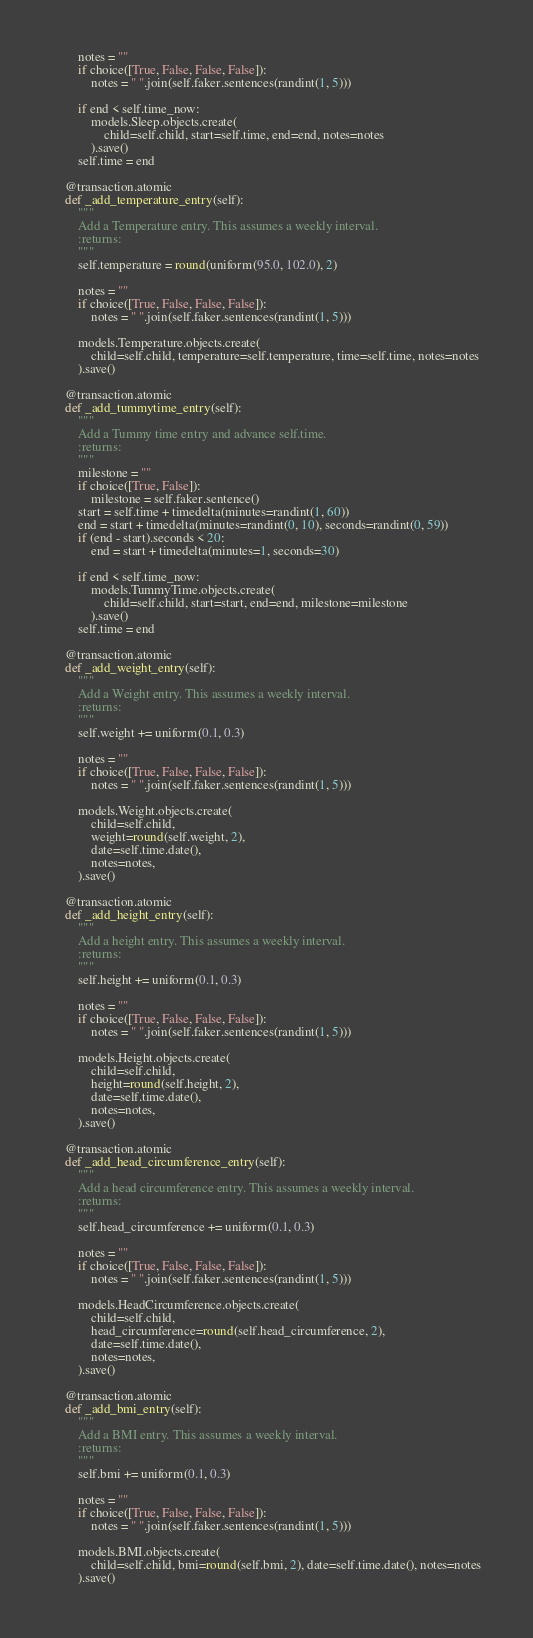Convert code to text. <code><loc_0><loc_0><loc_500><loc_500><_Python_>        notes = ""
        if choice([True, False, False, False]):
            notes = " ".join(self.faker.sentences(randint(1, 5)))

        if end < self.time_now:
            models.Sleep.objects.create(
                child=self.child, start=self.time, end=end, notes=notes
            ).save()
        self.time = end

    @transaction.atomic
    def _add_temperature_entry(self):
        """
        Add a Temperature entry. This assumes a weekly interval.
        :returns:
        """
        self.temperature = round(uniform(95.0, 102.0), 2)

        notes = ""
        if choice([True, False, False, False]):
            notes = " ".join(self.faker.sentences(randint(1, 5)))

        models.Temperature.objects.create(
            child=self.child, temperature=self.temperature, time=self.time, notes=notes
        ).save()

    @transaction.atomic
    def _add_tummytime_entry(self):
        """
        Add a Tummy time entry and advance self.time.
        :returns:
        """
        milestone = ""
        if choice([True, False]):
            milestone = self.faker.sentence()
        start = self.time + timedelta(minutes=randint(1, 60))
        end = start + timedelta(minutes=randint(0, 10), seconds=randint(0, 59))
        if (end - start).seconds < 20:
            end = start + timedelta(minutes=1, seconds=30)

        if end < self.time_now:
            models.TummyTime.objects.create(
                child=self.child, start=start, end=end, milestone=milestone
            ).save()
        self.time = end

    @transaction.atomic
    def _add_weight_entry(self):
        """
        Add a Weight entry. This assumes a weekly interval.
        :returns:
        """
        self.weight += uniform(0.1, 0.3)

        notes = ""
        if choice([True, False, False, False]):
            notes = " ".join(self.faker.sentences(randint(1, 5)))

        models.Weight.objects.create(
            child=self.child,
            weight=round(self.weight, 2),
            date=self.time.date(),
            notes=notes,
        ).save()

    @transaction.atomic
    def _add_height_entry(self):
        """
        Add a height entry. This assumes a weekly interval.
        :returns:
        """
        self.height += uniform(0.1, 0.3)

        notes = ""
        if choice([True, False, False, False]):
            notes = " ".join(self.faker.sentences(randint(1, 5)))

        models.Height.objects.create(
            child=self.child,
            height=round(self.height, 2),
            date=self.time.date(),
            notes=notes,
        ).save()

    @transaction.atomic
    def _add_head_circumference_entry(self):
        """
        Add a head circumference entry. This assumes a weekly interval.
        :returns:
        """
        self.head_circumference += uniform(0.1, 0.3)

        notes = ""
        if choice([True, False, False, False]):
            notes = " ".join(self.faker.sentences(randint(1, 5)))

        models.HeadCircumference.objects.create(
            child=self.child,
            head_circumference=round(self.head_circumference, 2),
            date=self.time.date(),
            notes=notes,
        ).save()

    @transaction.atomic
    def _add_bmi_entry(self):
        """
        Add a BMI entry. This assumes a weekly interval.
        :returns:
        """
        self.bmi += uniform(0.1, 0.3)

        notes = ""
        if choice([True, False, False, False]):
            notes = " ".join(self.faker.sentences(randint(1, 5)))

        models.BMI.objects.create(
            child=self.child, bmi=round(self.bmi, 2), date=self.time.date(), notes=notes
        ).save()
</code> 